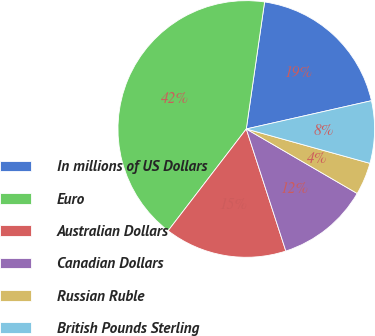<chart> <loc_0><loc_0><loc_500><loc_500><pie_chart><fcel>In millions of US Dollars<fcel>Euro<fcel>Australian Dollars<fcel>Canadian Dollars<fcel>Russian Ruble<fcel>British Pounds Sterling<nl><fcel>19.19%<fcel>41.86%<fcel>15.41%<fcel>11.63%<fcel>4.07%<fcel>7.85%<nl></chart> 